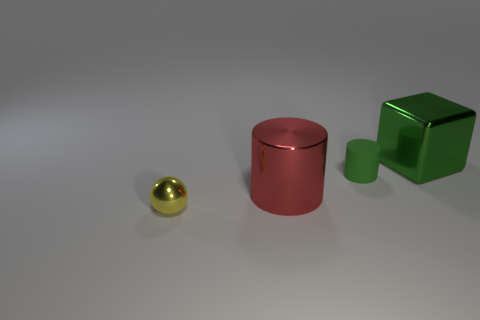What could be the possible usage of these objects given their shapes? The spherical object could serve as a decorative element or a part of a larger mechanical assembly, given its smooth, metallic finish. The cylindrical object might be a container or a stand, while the cube, with its distinct green color, could be a children's toy or a building block for creative play. 